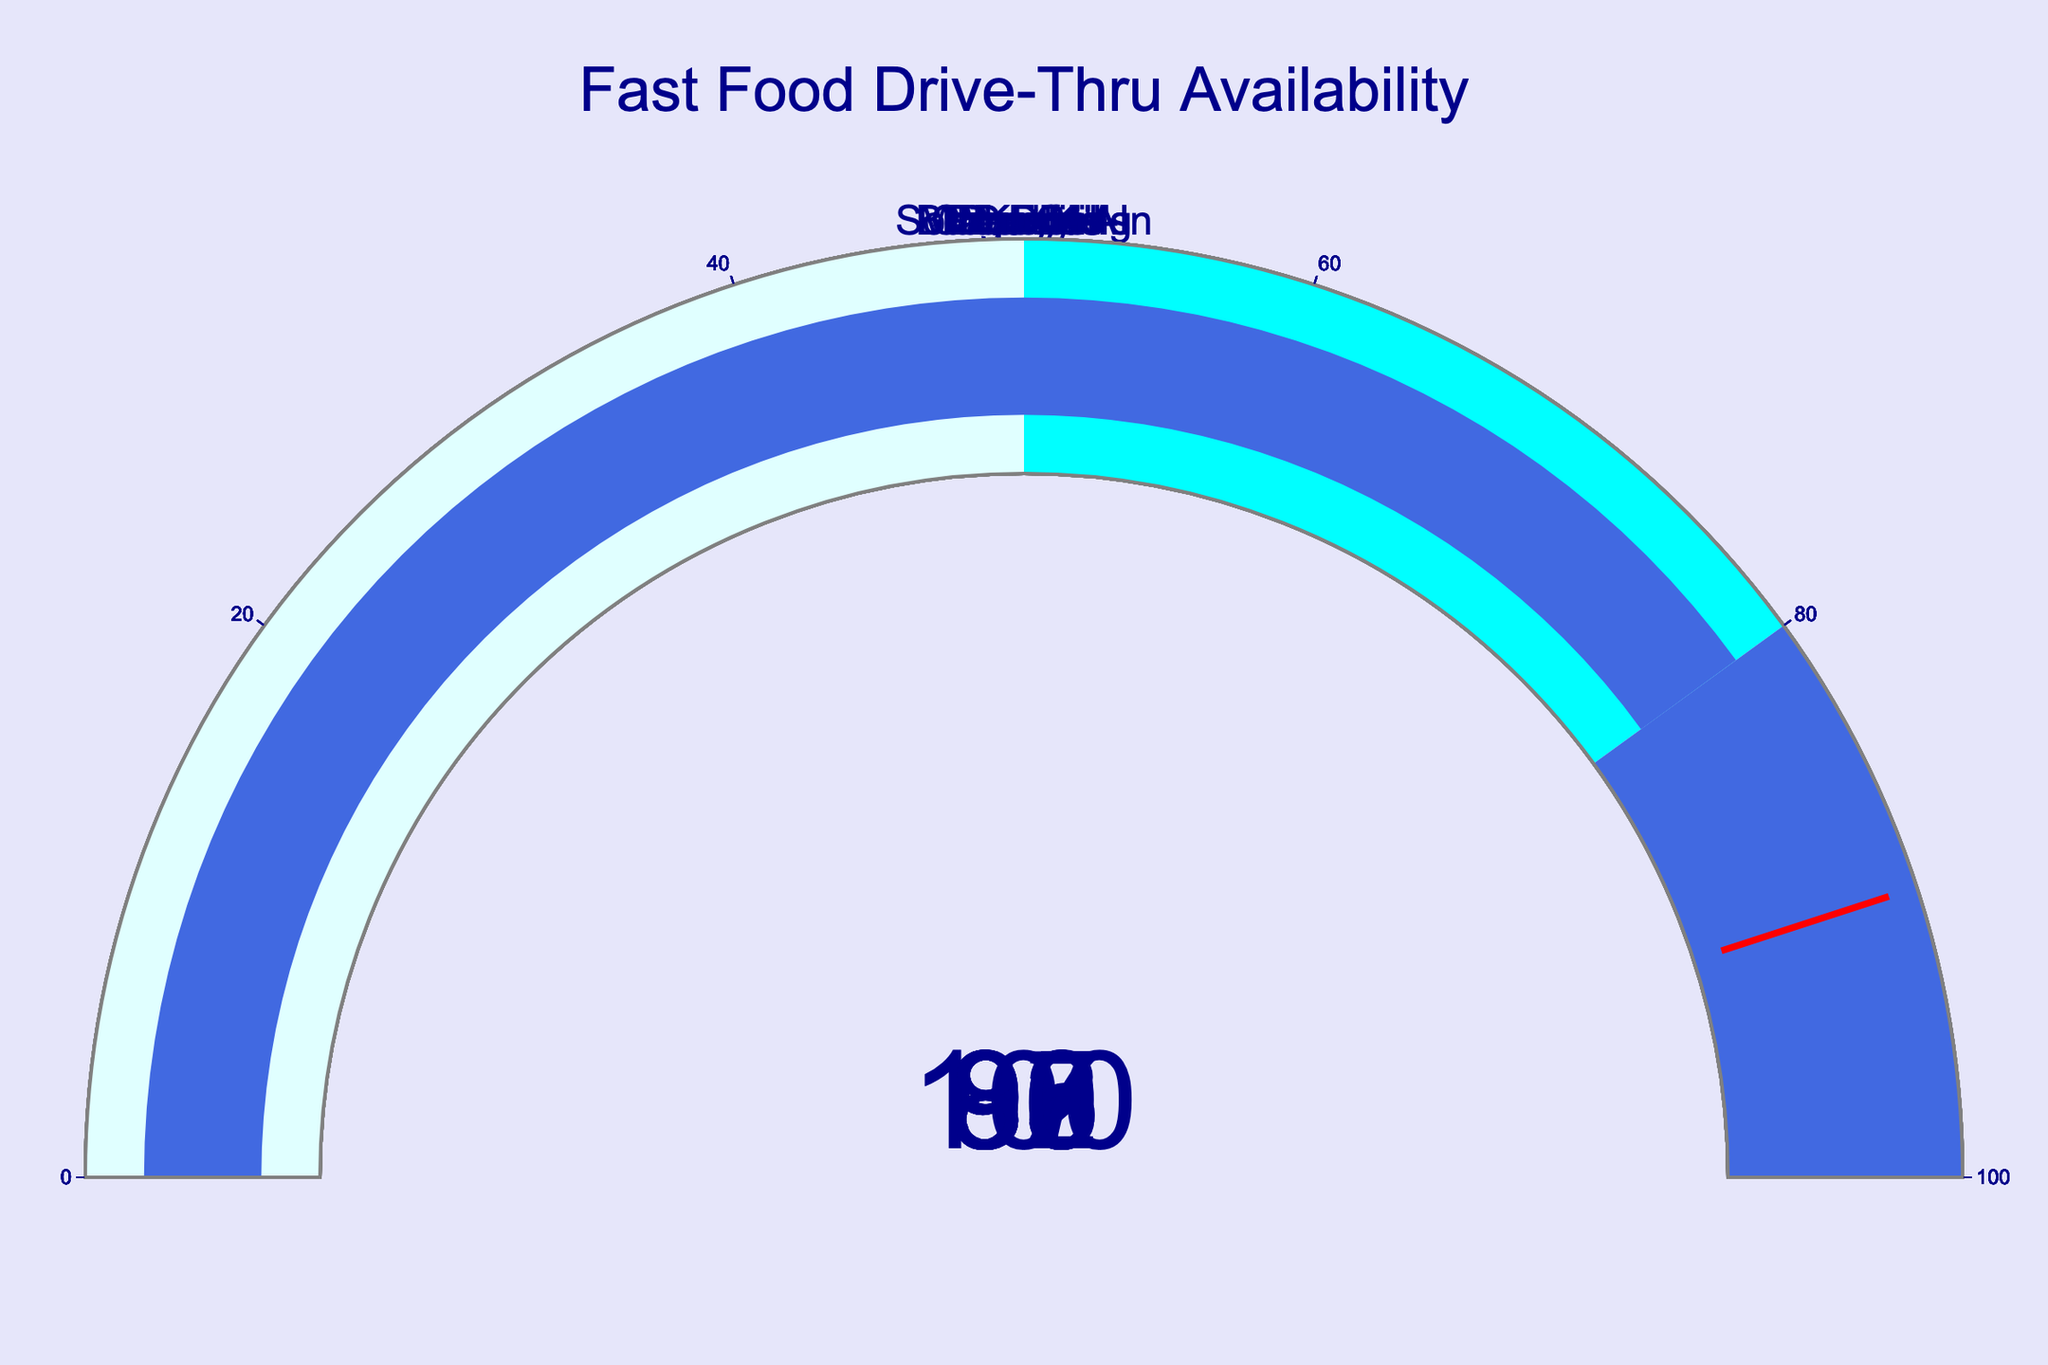What is the title of the figure? The title of the figure is usually displayed prominently at the top of the chart. Here, it specifies the context of the data being shown.
Answer: Fast Food Drive-Thru Availability What percentage of Sonic Drive-In locations offer drive-thru service? To find the percentage, look for the gauge labeled "Sonic Drive-In" and read the value indicated.
Answer: 100 Which restaurant has the lowest percentage of drive-thru service availability? Compare the values on each gauge and identify the smallest one. Dunkin' has the lowest percentage among all the restaurants.
Answer: Dunkin' What is the average percentage of drive-thru service availability across all listed restaurants? Sum the percentages of all the restaurants and divide by the number of restaurants ((95+90+92+88+85+93+100+87+86+80)/10) = 89.6
Answer: 89.6 How many restaurants have more than 90% drive-thru service availability? Count the number of gauges with values greater than 90% (McDonald's, Burger King, Wendy's, Chick-fil-A, Sonic Drive-In).
Answer: 5 What is the difference in drive-thru availability between McDonald's and KFC? Subtract the percentage of KFC from McDonald's (95 - 85).
Answer: 10 Which restaurants fall into the middle range of the gauge (50-80%)? Identify the gauges with values within 50-80%. Only Dunkin', with 80%, falls into the specified range.
Answer: Dunkin' Which restaurant has a higher drive-thru percentage, Popeyes or Taco Bell? Compare the values on the gauges for Popeyes and Taco Bell. Both are close, but figure out which has the higher number.
Answer: Taco Bell 